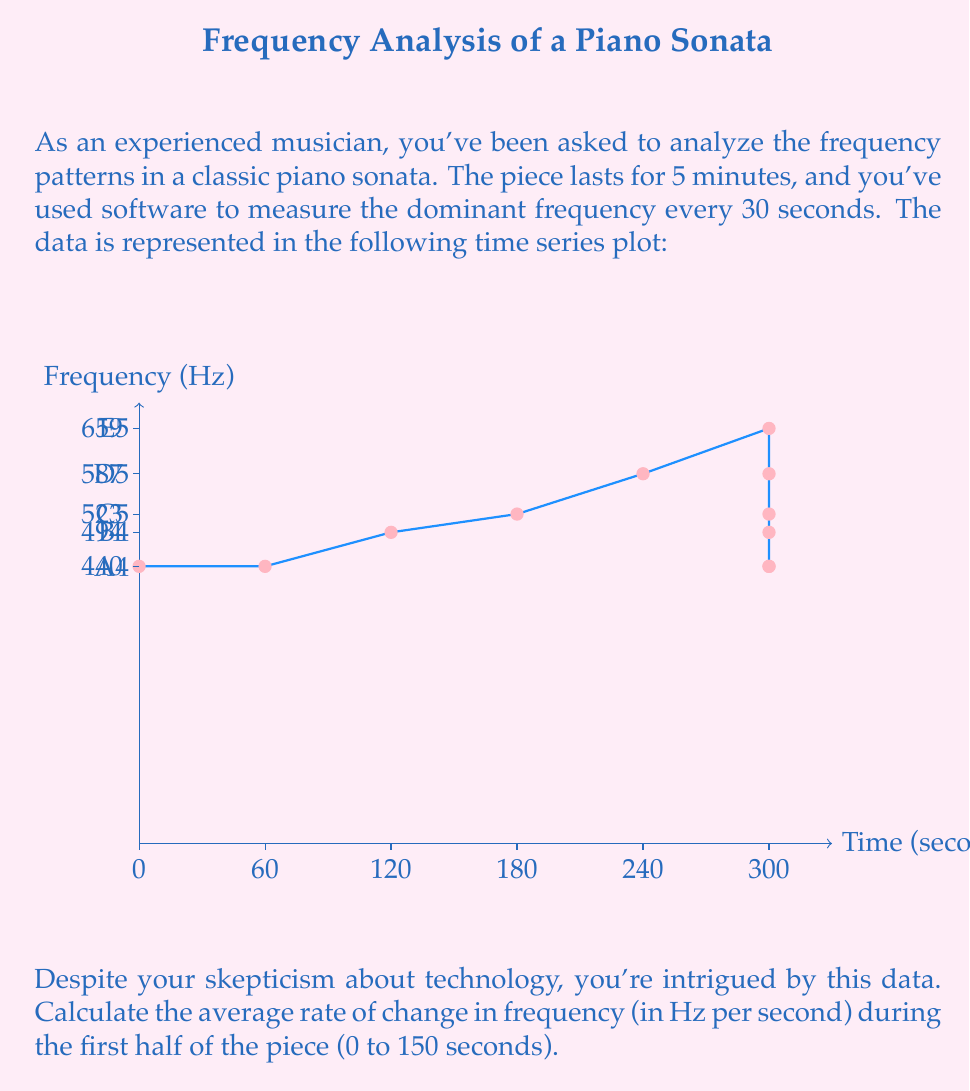Can you solve this math problem? Let's approach this step-by-step:

1) First, we need to identify the relevant data points:
   At t = 0 seconds, frequency = 440 Hz
   At t = 150 seconds, frequency = 659 Hz

2) The average rate of change is calculated using the formula:

   $$\text{Average rate of change} = \frac{\text{Change in y}}{\text{Change in x}} = \frac{\Delta y}{\Delta x}$$

3) In this case:
   $\Delta y = \text{Final frequency} - \text{Initial frequency} = 659 \text{ Hz} - 440 \text{ Hz} = 219 \text{ Hz}$
   $\Delta x = \text{Final time} - \text{Initial time} = 150 \text{ s} - 0 \text{ s} = 150 \text{ s}$

4) Substituting these values into our formula:

   $$\text{Average rate of change} = \frac{219 \text{ Hz}}{150 \text{ s}}$$

5) Simplifying:

   $$\text{Average rate of change} = 1.46 \text{ Hz/s}$$

Therefore, the average rate of change in frequency during the first half of the piece is 1.46 Hz per second.
Answer: 1.46 Hz/s 